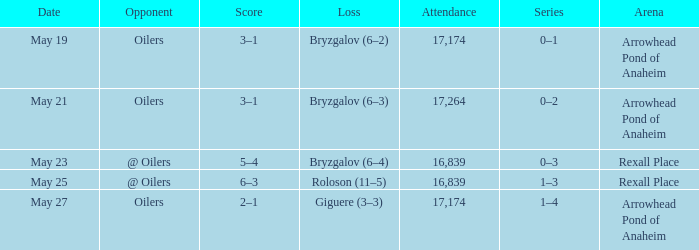How much attendance has a Loss of roloson (11–5)? 16839.0. 